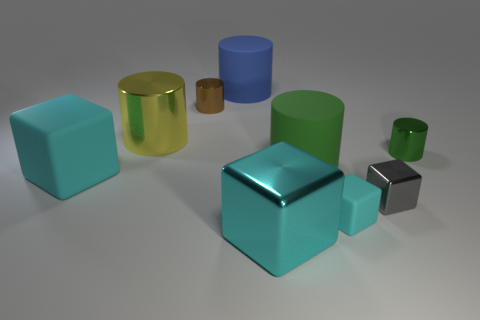How many cyan blocks must be subtracted to get 2 cyan blocks? 1 Subtract all cyan spheres. How many cyan cubes are left? 3 Subtract all brown cylinders. How many cylinders are left? 4 Subtract all brown metal cylinders. How many cylinders are left? 4 Subtract 1 cylinders. How many cylinders are left? 4 Subtract all cyan cylinders. Subtract all brown spheres. How many cylinders are left? 5 Add 1 big yellow metallic objects. How many objects exist? 10 Subtract all cylinders. How many objects are left? 4 Add 7 metal cylinders. How many metal cylinders exist? 10 Subtract 0 purple cylinders. How many objects are left? 9 